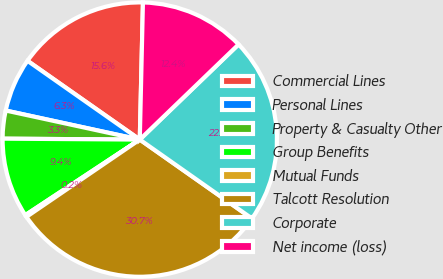Convert chart to OTSL. <chart><loc_0><loc_0><loc_500><loc_500><pie_chart><fcel>Commercial Lines<fcel>Personal Lines<fcel>Property & Casualty Other<fcel>Group Benefits<fcel>Mutual Funds<fcel>Talcott Resolution<fcel>Corporate<fcel>Net income (loss)<nl><fcel>15.63%<fcel>6.34%<fcel>3.29%<fcel>9.39%<fcel>0.24%<fcel>30.72%<fcel>21.96%<fcel>12.43%<nl></chart> 